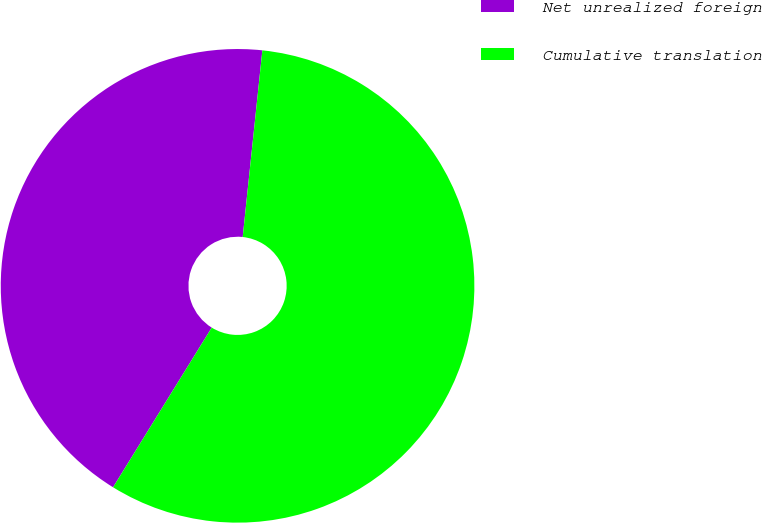Convert chart to OTSL. <chart><loc_0><loc_0><loc_500><loc_500><pie_chart><fcel>Net unrealized foreign<fcel>Cumulative translation<nl><fcel>42.86%<fcel>57.14%<nl></chart> 